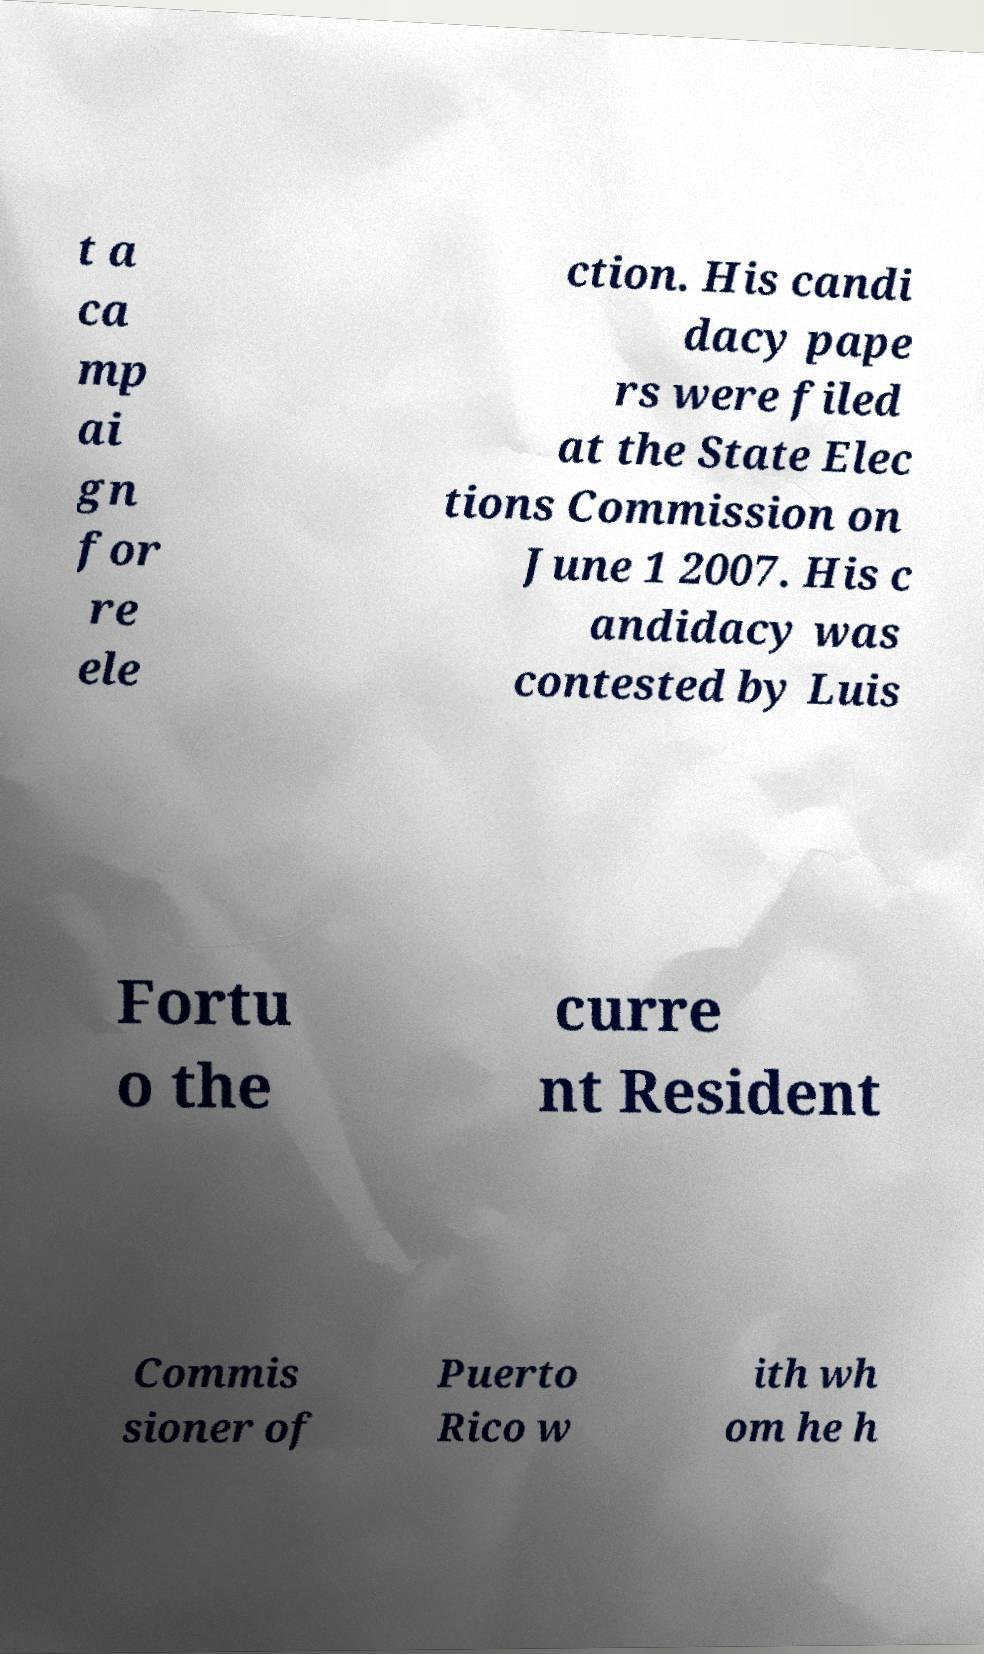I need the written content from this picture converted into text. Can you do that? t a ca mp ai gn for re ele ction. His candi dacy pape rs were filed at the State Elec tions Commission on June 1 2007. His c andidacy was contested by Luis Fortu o the curre nt Resident Commis sioner of Puerto Rico w ith wh om he h 